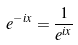Convert formula to latex. <formula><loc_0><loc_0><loc_500><loc_500>e ^ { - i x } = \frac { 1 } { e ^ { i x } }</formula> 